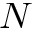Convert formula to latex. <formula><loc_0><loc_0><loc_500><loc_500>N</formula> 